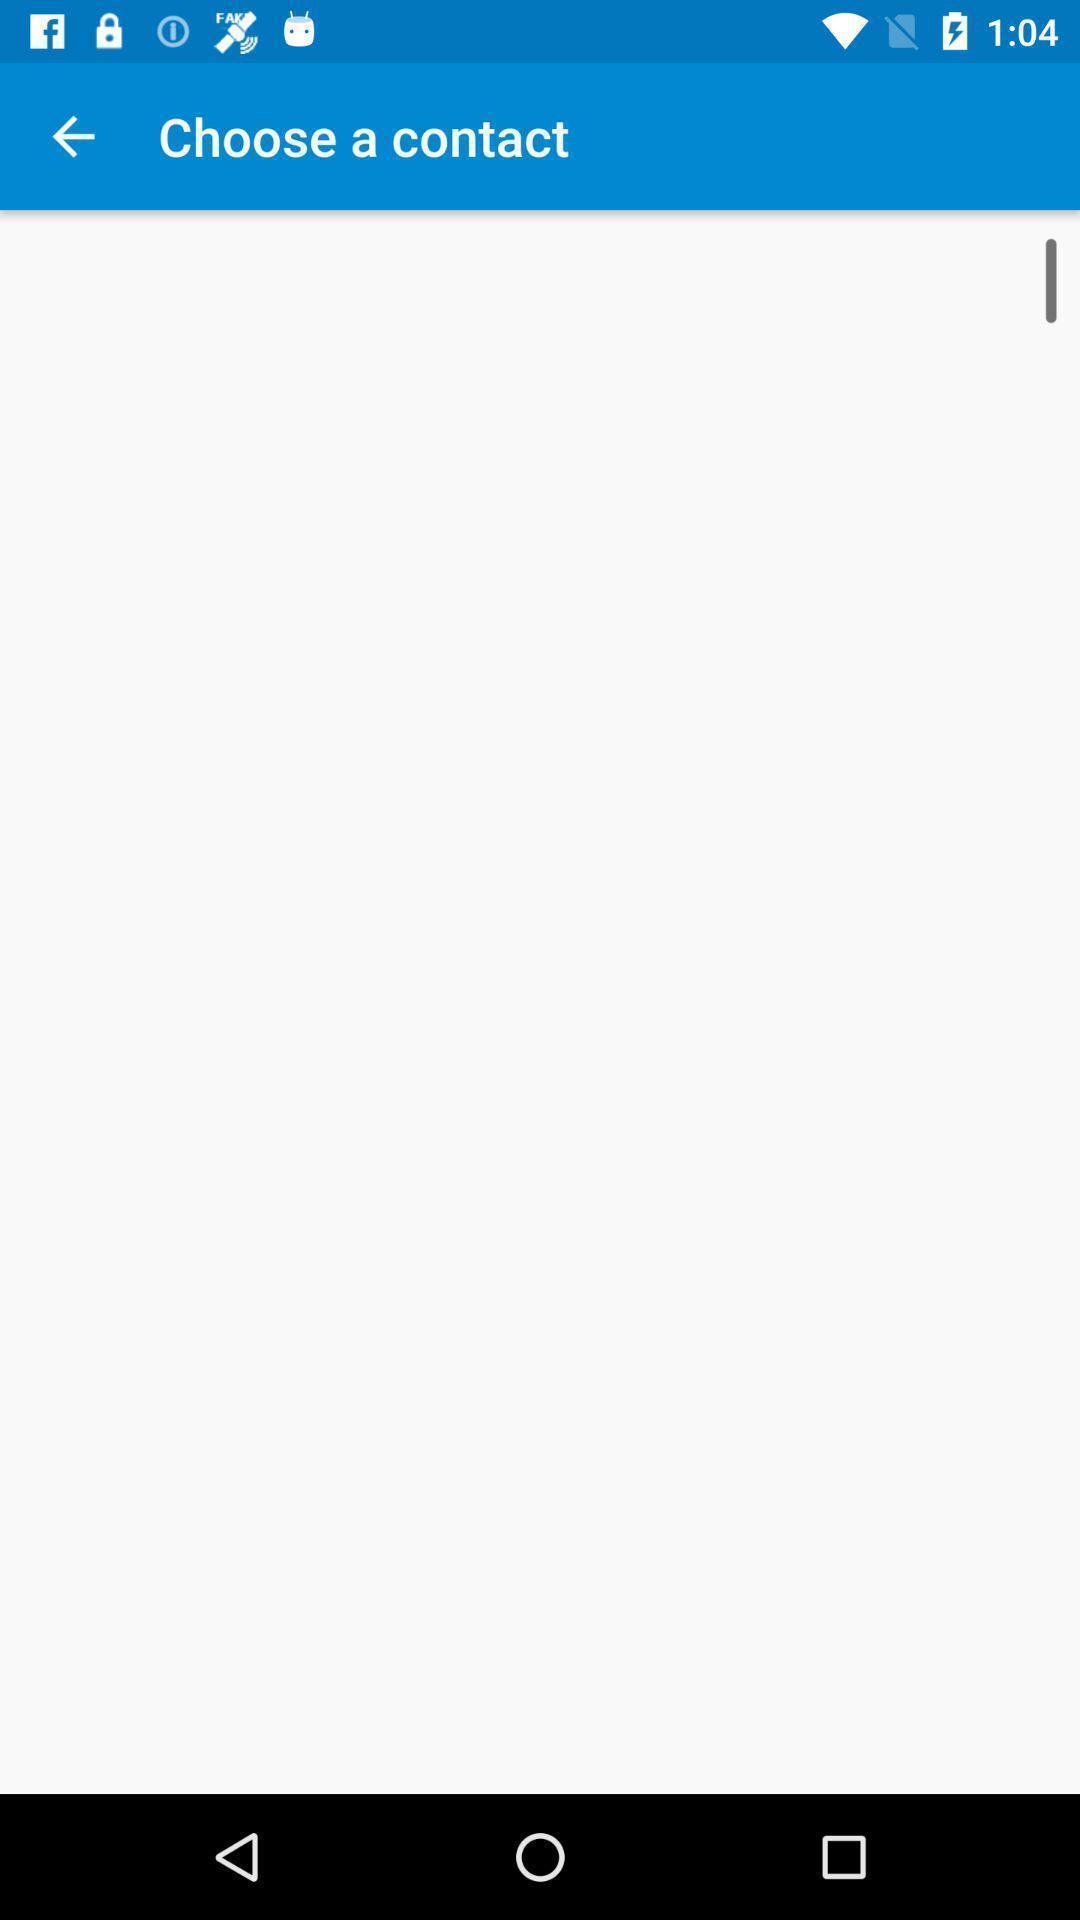Describe the key features of this screenshot. Page displaying to choose a contact. 